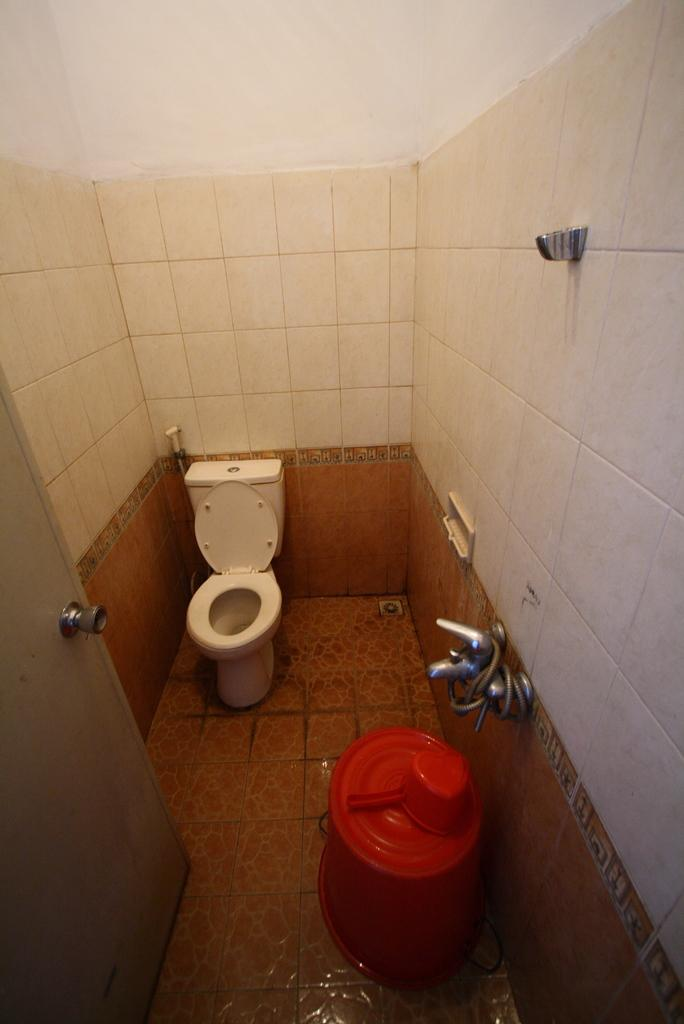Where was the image taken? The image was taken in a bathroom. What objects can be seen in the bathroom? There is a bucket, a mug, a tap, a pipe, a toilet, a door, a wall, and a floor in the image. Can you describe the water source in the bathroom? There is a tap in the image, which is likely the water source. What type of fixture is present for waste disposal? There is a toilet in the image, which is used for waste disposal. What type of part is needed to fix the tub in the image? There is no tub present in the image, so no parts are needed for fixing a tub. 